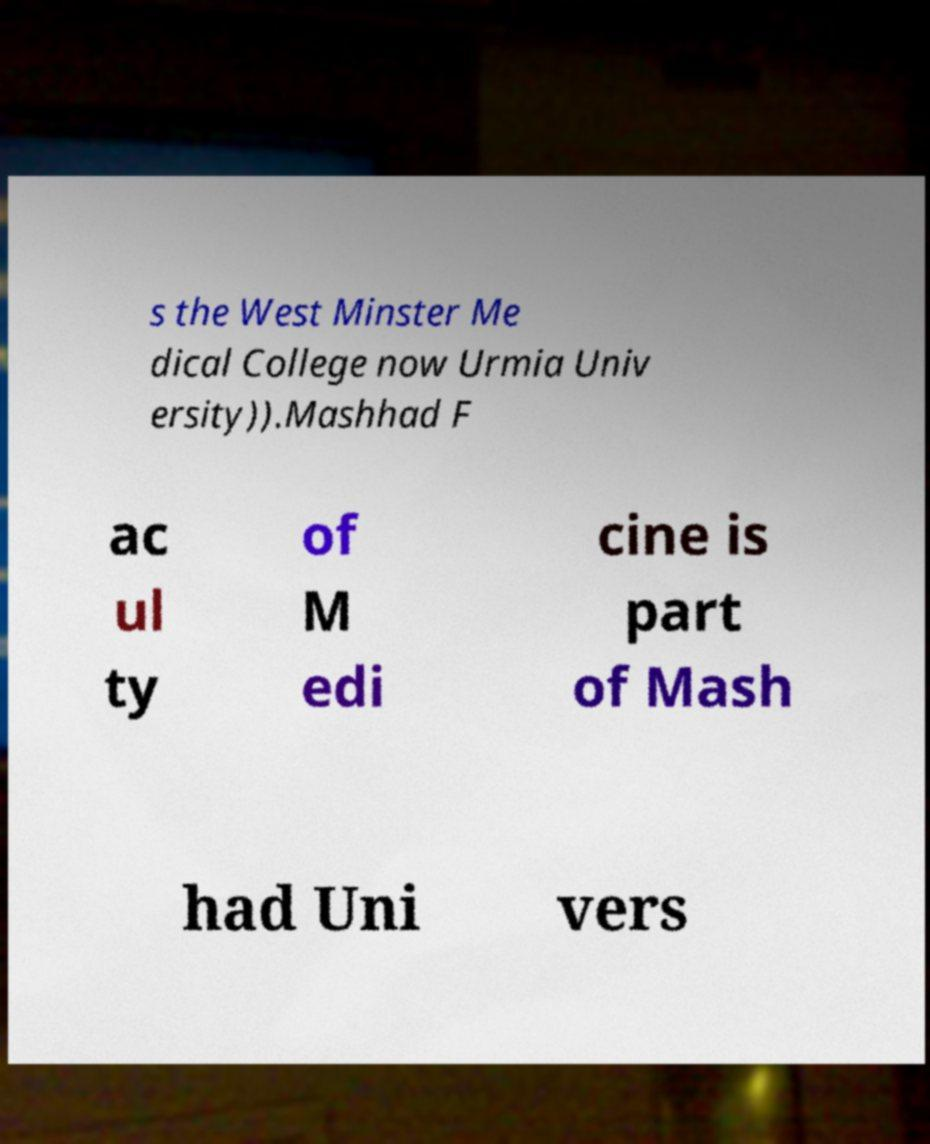Can you read and provide the text displayed in the image?This photo seems to have some interesting text. Can you extract and type it out for me? s the West Minster Me dical College now Urmia Univ ersity)).Mashhad F ac ul ty of M edi cine is part of Mash had Uni vers 